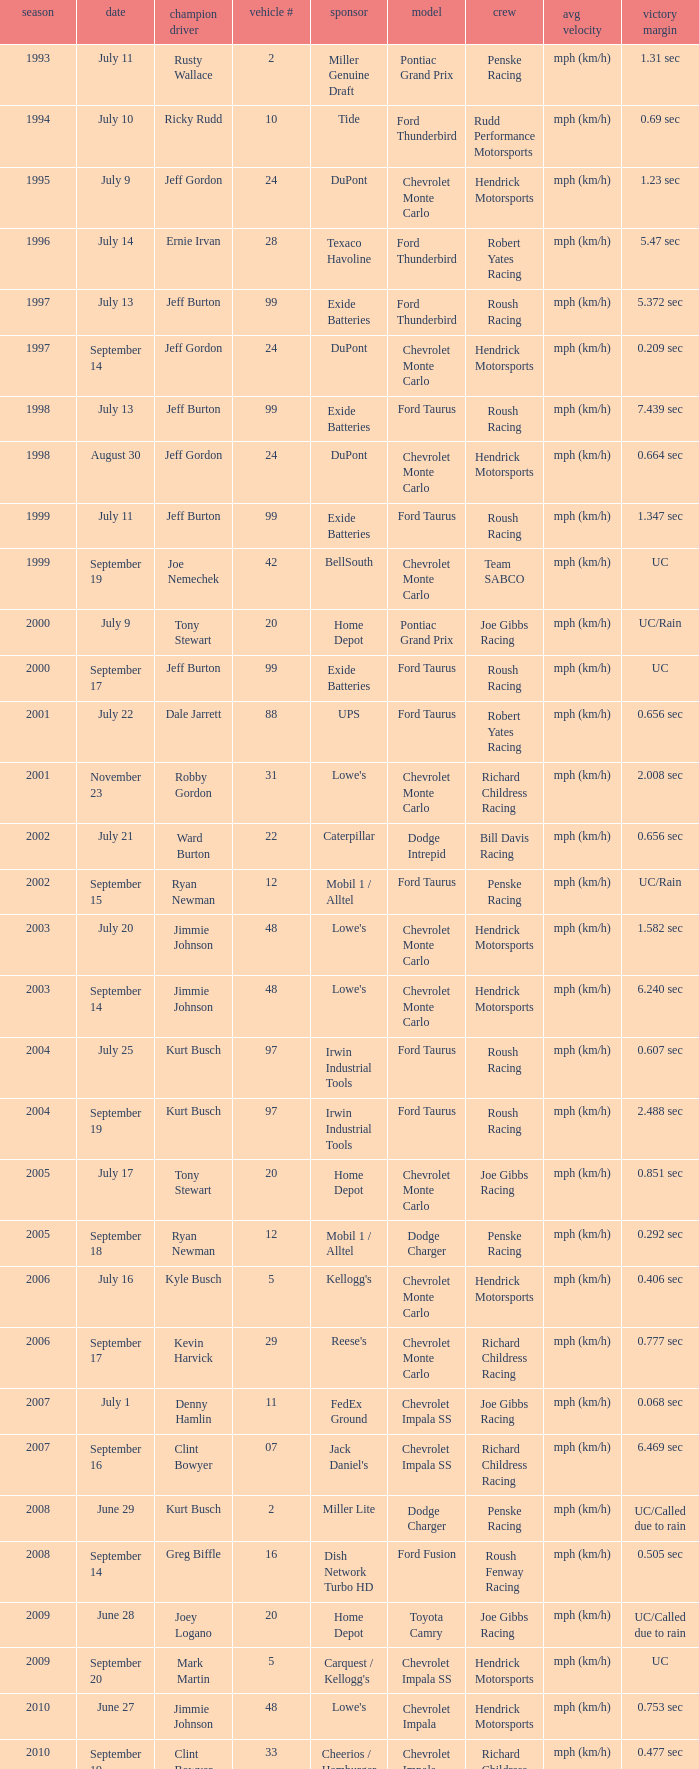What team ran car #24 on August 30? Hendrick Motorsports. Could you help me parse every detail presented in this table? {'header': ['season', 'date', 'champion driver', 'vehicle #', 'sponsor', 'model', 'crew', 'avg velocity', 'victory margin'], 'rows': [['1993', 'July 11', 'Rusty Wallace', '2', 'Miller Genuine Draft', 'Pontiac Grand Prix', 'Penske Racing', 'mph (km/h)', '1.31 sec'], ['1994', 'July 10', 'Ricky Rudd', '10', 'Tide', 'Ford Thunderbird', 'Rudd Performance Motorsports', 'mph (km/h)', '0.69 sec'], ['1995', 'July 9', 'Jeff Gordon', '24', 'DuPont', 'Chevrolet Monte Carlo', 'Hendrick Motorsports', 'mph (km/h)', '1.23 sec'], ['1996', 'July 14', 'Ernie Irvan', '28', 'Texaco Havoline', 'Ford Thunderbird', 'Robert Yates Racing', 'mph (km/h)', '5.47 sec'], ['1997', 'July 13', 'Jeff Burton', '99', 'Exide Batteries', 'Ford Thunderbird', 'Roush Racing', 'mph (km/h)', '5.372 sec'], ['1997', 'September 14', 'Jeff Gordon', '24', 'DuPont', 'Chevrolet Monte Carlo', 'Hendrick Motorsports', 'mph (km/h)', '0.209 sec'], ['1998', 'July 13', 'Jeff Burton', '99', 'Exide Batteries', 'Ford Taurus', 'Roush Racing', 'mph (km/h)', '7.439 sec'], ['1998', 'August 30', 'Jeff Gordon', '24', 'DuPont', 'Chevrolet Monte Carlo', 'Hendrick Motorsports', 'mph (km/h)', '0.664 sec'], ['1999', 'July 11', 'Jeff Burton', '99', 'Exide Batteries', 'Ford Taurus', 'Roush Racing', 'mph (km/h)', '1.347 sec'], ['1999', 'September 19', 'Joe Nemechek', '42', 'BellSouth', 'Chevrolet Monte Carlo', 'Team SABCO', 'mph (km/h)', 'UC'], ['2000', 'July 9', 'Tony Stewart', '20', 'Home Depot', 'Pontiac Grand Prix', 'Joe Gibbs Racing', 'mph (km/h)', 'UC/Rain'], ['2000', 'September 17', 'Jeff Burton', '99', 'Exide Batteries', 'Ford Taurus', 'Roush Racing', 'mph (km/h)', 'UC'], ['2001', 'July 22', 'Dale Jarrett', '88', 'UPS', 'Ford Taurus', 'Robert Yates Racing', 'mph (km/h)', '0.656 sec'], ['2001', 'November 23', 'Robby Gordon', '31', "Lowe's", 'Chevrolet Monte Carlo', 'Richard Childress Racing', 'mph (km/h)', '2.008 sec'], ['2002', 'July 21', 'Ward Burton', '22', 'Caterpillar', 'Dodge Intrepid', 'Bill Davis Racing', 'mph (km/h)', '0.656 sec'], ['2002', 'September 15', 'Ryan Newman', '12', 'Mobil 1 / Alltel', 'Ford Taurus', 'Penske Racing', 'mph (km/h)', 'UC/Rain'], ['2003', 'July 20', 'Jimmie Johnson', '48', "Lowe's", 'Chevrolet Monte Carlo', 'Hendrick Motorsports', 'mph (km/h)', '1.582 sec'], ['2003', 'September 14', 'Jimmie Johnson', '48', "Lowe's", 'Chevrolet Monte Carlo', 'Hendrick Motorsports', 'mph (km/h)', '6.240 sec'], ['2004', 'July 25', 'Kurt Busch', '97', 'Irwin Industrial Tools', 'Ford Taurus', 'Roush Racing', 'mph (km/h)', '0.607 sec'], ['2004', 'September 19', 'Kurt Busch', '97', 'Irwin Industrial Tools', 'Ford Taurus', 'Roush Racing', 'mph (km/h)', '2.488 sec'], ['2005', 'July 17', 'Tony Stewart', '20', 'Home Depot', 'Chevrolet Monte Carlo', 'Joe Gibbs Racing', 'mph (km/h)', '0.851 sec'], ['2005', 'September 18', 'Ryan Newman', '12', 'Mobil 1 / Alltel', 'Dodge Charger', 'Penske Racing', 'mph (km/h)', '0.292 sec'], ['2006', 'July 16', 'Kyle Busch', '5', "Kellogg's", 'Chevrolet Monte Carlo', 'Hendrick Motorsports', 'mph (km/h)', '0.406 sec'], ['2006', 'September 17', 'Kevin Harvick', '29', "Reese's", 'Chevrolet Monte Carlo', 'Richard Childress Racing', 'mph (km/h)', '0.777 sec'], ['2007', 'July 1', 'Denny Hamlin', '11', 'FedEx Ground', 'Chevrolet Impala SS', 'Joe Gibbs Racing', 'mph (km/h)', '0.068 sec'], ['2007', 'September 16', 'Clint Bowyer', '07', "Jack Daniel's", 'Chevrolet Impala SS', 'Richard Childress Racing', 'mph (km/h)', '6.469 sec'], ['2008', 'June 29', 'Kurt Busch', '2', 'Miller Lite', 'Dodge Charger', 'Penske Racing', 'mph (km/h)', 'UC/Called due to rain'], ['2008', 'September 14', 'Greg Biffle', '16', 'Dish Network Turbo HD', 'Ford Fusion', 'Roush Fenway Racing', 'mph (km/h)', '0.505 sec'], ['2009', 'June 28', 'Joey Logano', '20', 'Home Depot', 'Toyota Camry', 'Joe Gibbs Racing', 'mph (km/h)', 'UC/Called due to rain'], ['2009', 'September 20', 'Mark Martin', '5', "Carquest / Kellogg's", 'Chevrolet Impala SS', 'Hendrick Motorsports', 'mph (km/h)', 'UC'], ['2010', 'June 27', 'Jimmie Johnson', '48', "Lowe's", 'Chevrolet Impala', 'Hendrick Motorsports', 'mph (km/h)', '0.753 sec'], ['2010', 'September 19', 'Clint Bowyer', '33', 'Cheerios / Hamburger Helper', 'Chevrolet Impala', 'Richard Childress Racing', 'mph (km/h)', '0.477 sec'], ['2011', 'July 17', 'Ryan Newman', '39', 'U.S. Army', 'Chevrolet Impala', 'Stewart-Haas Racing', 'mph (km/h)', '0.773 sec'], ['2011', 'September 25', 'Tony Stewart', '14', 'Mobil 1 / Office Depot', 'Chevrolet Impala', 'Stewart-Haas Racing', 'mph (km/h)', '7.225 sec'], ['2012', 'July 15', 'Kasey Kahne', '5', 'Farmers Insurance', 'Chevrolet Impala', 'Hendrick Motorsports', 'mph (km/h)', '2.738 sec'], ['2012', 'September 23', 'Denny Hamlin', '11', 'FedEx Freight', 'Toyota Camry', 'Joe Gibbs Racing', 'mph (km/h)', '2.675 sec'], ['2013', 'July 14', 'Brian Vickers', '55', "Aaron's", 'Toyota Camry', 'Michael Waltrip Racing', 'mph (km/h)', '.582 sec'], ['2013', 'September 22', 'Matt Kenseth', '20', 'Husky Tools', 'Toyota Camry', 'Joe Gibbs Racing', 'mph (km/h)', '.533 sec']]} 